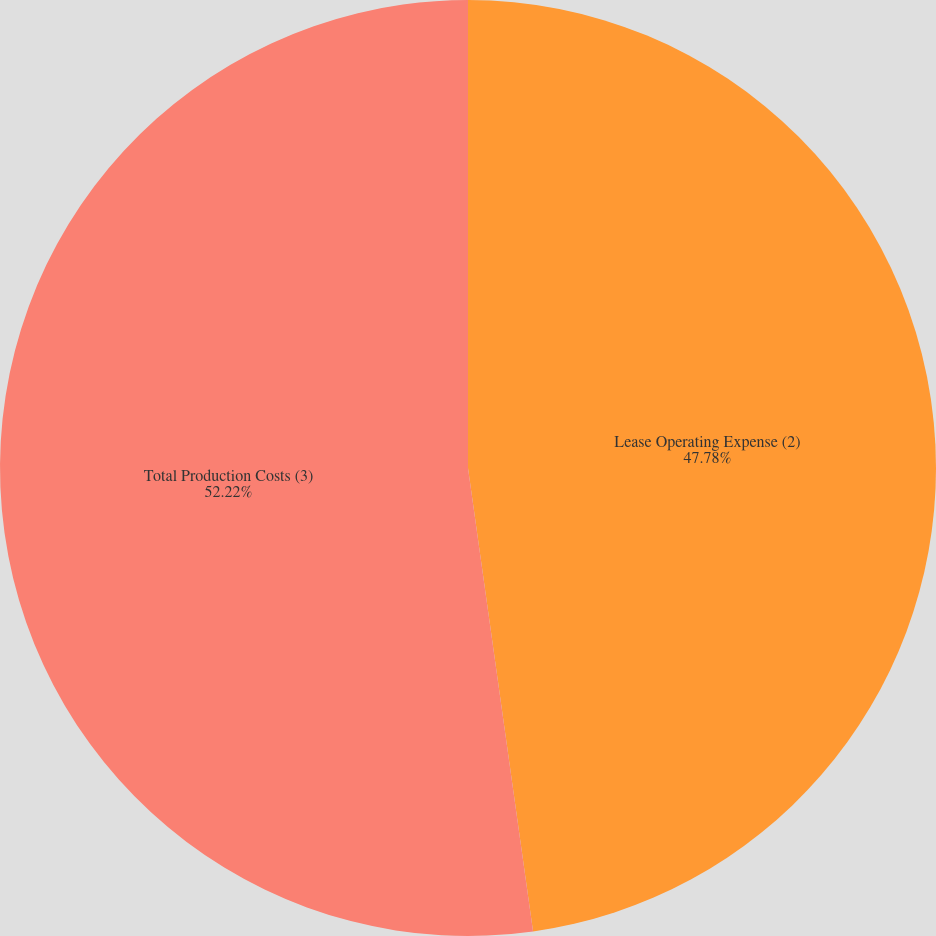<chart> <loc_0><loc_0><loc_500><loc_500><pie_chart><fcel>Lease Operating Expense (2)<fcel>Total Production Costs (3)<nl><fcel>47.78%<fcel>52.22%<nl></chart> 